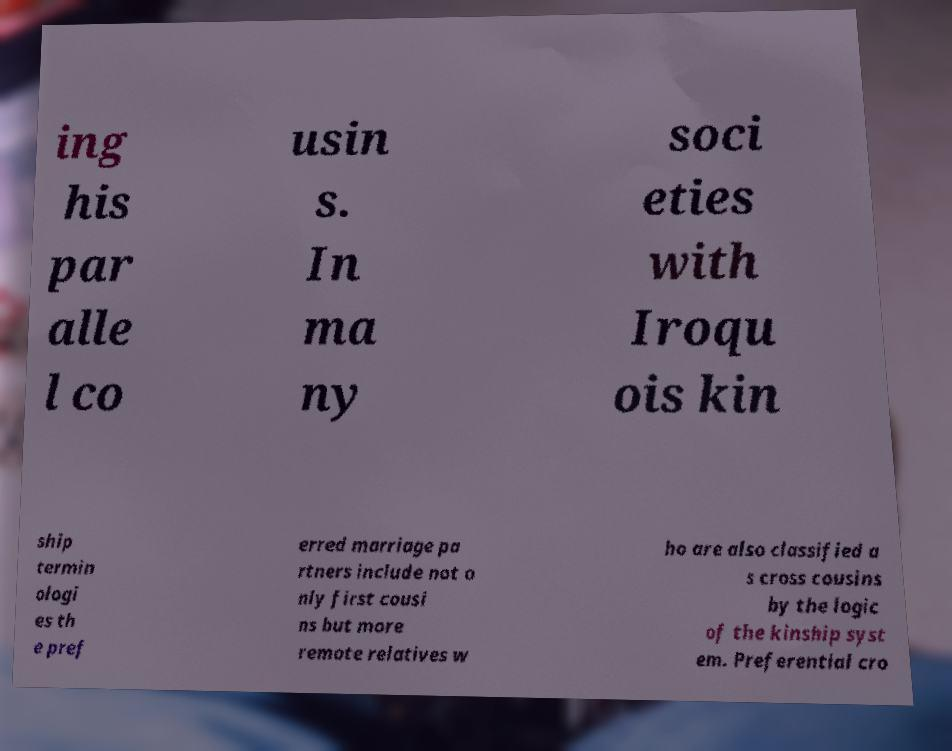For documentation purposes, I need the text within this image transcribed. Could you provide that? ing his par alle l co usin s. In ma ny soci eties with Iroqu ois kin ship termin ologi es th e pref erred marriage pa rtners include not o nly first cousi ns but more remote relatives w ho are also classified a s cross cousins by the logic of the kinship syst em. Preferential cro 